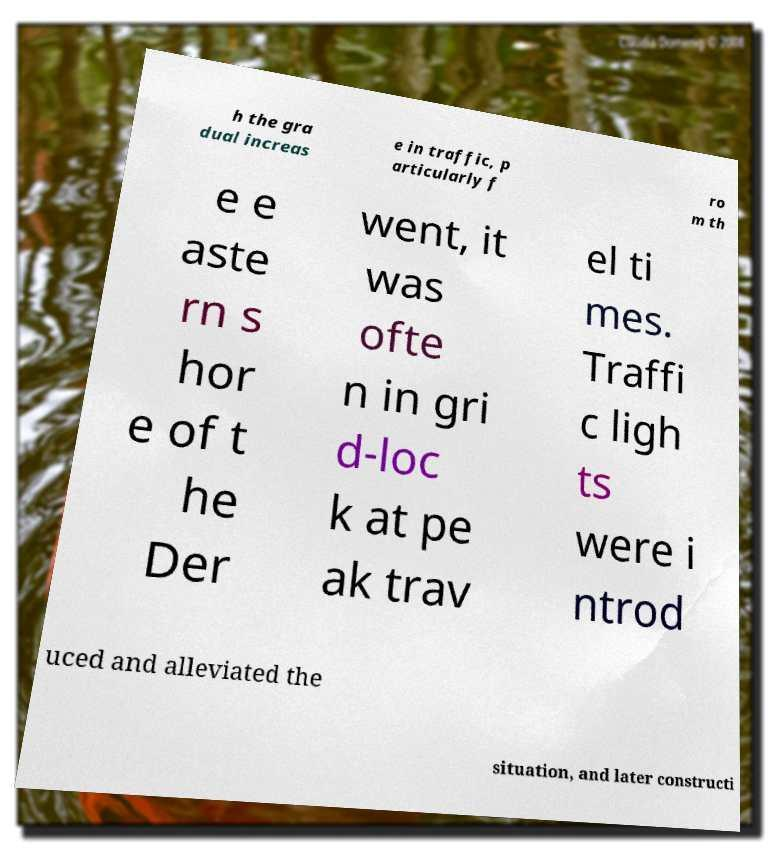I need the written content from this picture converted into text. Can you do that? h the gra dual increas e in traffic, p articularly f ro m th e e aste rn s hor e of t he Der went, it was ofte n in gri d-loc k at pe ak trav el ti mes. Traffi c ligh ts were i ntrod uced and alleviated the situation, and later constructi 